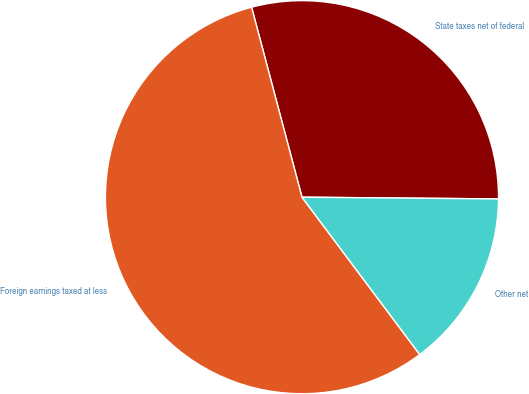Convert chart to OTSL. <chart><loc_0><loc_0><loc_500><loc_500><pie_chart><fcel>State taxes net of federal<fcel>Foreign earnings taxed at less<fcel>Other net<nl><fcel>29.27%<fcel>56.1%<fcel>14.63%<nl></chart> 